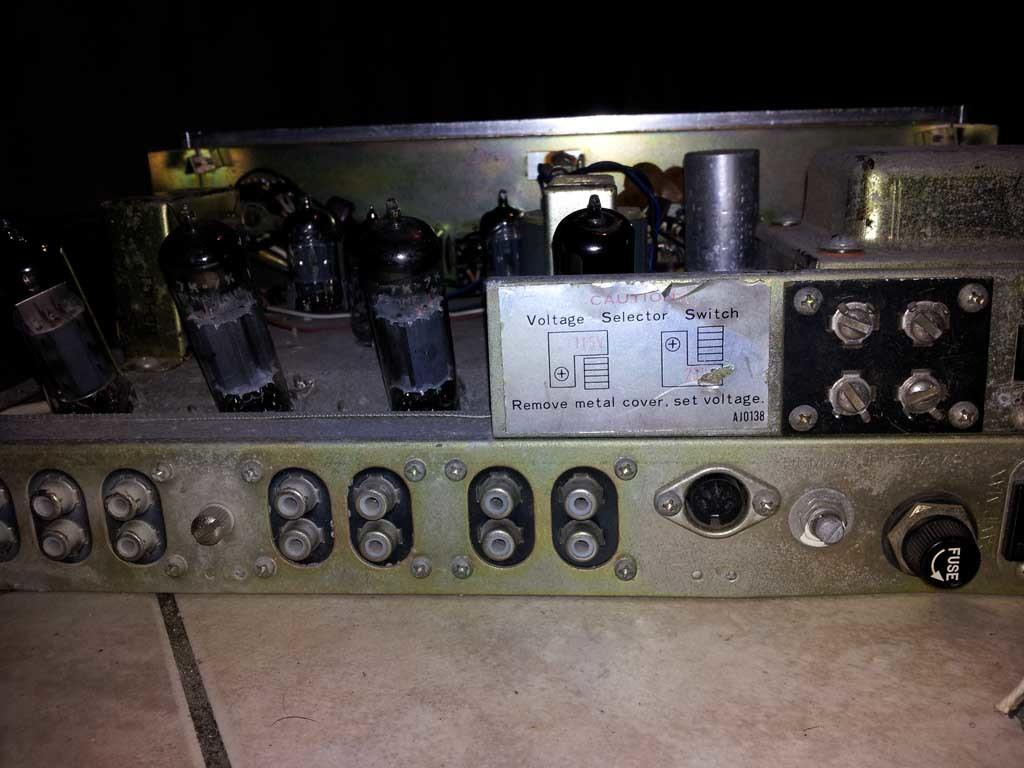What type of object is located on the floor in the image? There is an electronic device on the floor in the image. What feature does the electronic device have? The electronic device has knobs. Is there any additional information attached to the device? Yes, there is a white color paper attached to the device. What can be found on the paper? The paper has text on it. How many eyes can be seen on the electronic device in the image? There are no eyes visible on the electronic device in the image. What type of spoon is used to stir the current in the image? There is no spoon or current present in the image; it features an electronic device with a paper attached to it. 